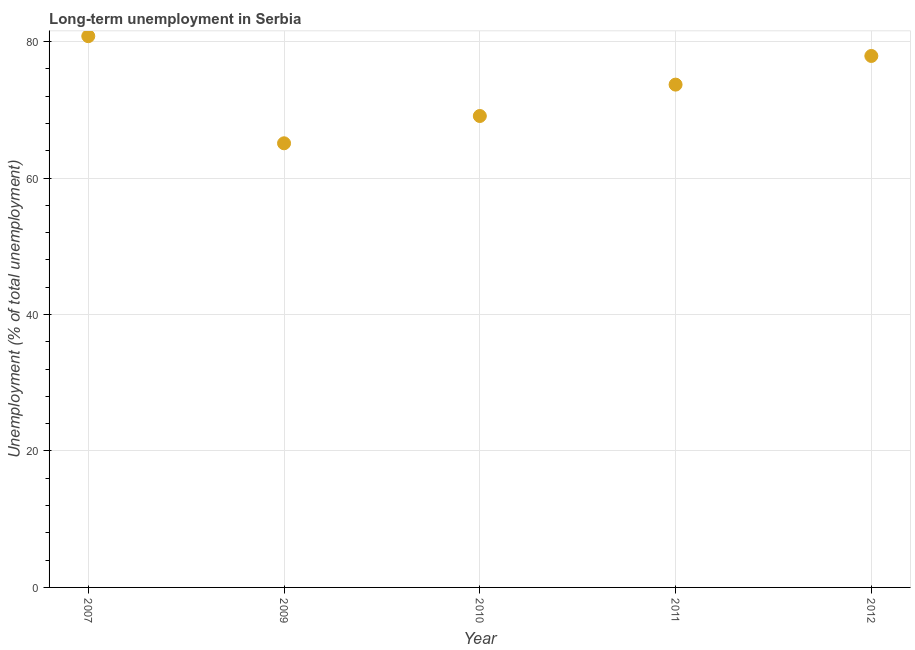What is the long-term unemployment in 2010?
Your answer should be very brief. 69.1. Across all years, what is the maximum long-term unemployment?
Offer a terse response. 80.8. Across all years, what is the minimum long-term unemployment?
Make the answer very short. 65.1. In which year was the long-term unemployment maximum?
Your answer should be compact. 2007. In which year was the long-term unemployment minimum?
Your answer should be compact. 2009. What is the sum of the long-term unemployment?
Your answer should be compact. 366.6. What is the difference between the long-term unemployment in 2009 and 2011?
Offer a very short reply. -8.6. What is the average long-term unemployment per year?
Your answer should be compact. 73.32. What is the median long-term unemployment?
Offer a terse response. 73.7. Do a majority of the years between 2010 and 2012 (inclusive) have long-term unemployment greater than 16 %?
Ensure brevity in your answer.  Yes. What is the ratio of the long-term unemployment in 2009 to that in 2010?
Provide a succinct answer. 0.94. Is the long-term unemployment in 2007 less than that in 2009?
Provide a short and direct response. No. What is the difference between the highest and the second highest long-term unemployment?
Your response must be concise. 2.9. What is the difference between the highest and the lowest long-term unemployment?
Make the answer very short. 15.7. Are the values on the major ticks of Y-axis written in scientific E-notation?
Offer a terse response. No. Does the graph contain any zero values?
Ensure brevity in your answer.  No. What is the title of the graph?
Offer a terse response. Long-term unemployment in Serbia. What is the label or title of the X-axis?
Your answer should be very brief. Year. What is the label or title of the Y-axis?
Give a very brief answer. Unemployment (% of total unemployment). What is the Unemployment (% of total unemployment) in 2007?
Your response must be concise. 80.8. What is the Unemployment (% of total unemployment) in 2009?
Make the answer very short. 65.1. What is the Unemployment (% of total unemployment) in 2010?
Your response must be concise. 69.1. What is the Unemployment (% of total unemployment) in 2011?
Make the answer very short. 73.7. What is the Unemployment (% of total unemployment) in 2012?
Provide a short and direct response. 77.9. What is the difference between the Unemployment (% of total unemployment) in 2007 and 2011?
Provide a short and direct response. 7.1. What is the difference between the Unemployment (% of total unemployment) in 2009 and 2010?
Your response must be concise. -4. What is the difference between the Unemployment (% of total unemployment) in 2009 and 2011?
Your answer should be compact. -8.6. What is the difference between the Unemployment (% of total unemployment) in 2009 and 2012?
Your response must be concise. -12.8. What is the difference between the Unemployment (% of total unemployment) in 2010 and 2011?
Your answer should be compact. -4.6. What is the difference between the Unemployment (% of total unemployment) in 2010 and 2012?
Make the answer very short. -8.8. What is the ratio of the Unemployment (% of total unemployment) in 2007 to that in 2009?
Give a very brief answer. 1.24. What is the ratio of the Unemployment (% of total unemployment) in 2007 to that in 2010?
Make the answer very short. 1.17. What is the ratio of the Unemployment (% of total unemployment) in 2007 to that in 2011?
Keep it short and to the point. 1.1. What is the ratio of the Unemployment (% of total unemployment) in 2007 to that in 2012?
Provide a succinct answer. 1.04. What is the ratio of the Unemployment (% of total unemployment) in 2009 to that in 2010?
Make the answer very short. 0.94. What is the ratio of the Unemployment (% of total unemployment) in 2009 to that in 2011?
Offer a very short reply. 0.88. What is the ratio of the Unemployment (% of total unemployment) in 2009 to that in 2012?
Offer a very short reply. 0.84. What is the ratio of the Unemployment (% of total unemployment) in 2010 to that in 2011?
Ensure brevity in your answer.  0.94. What is the ratio of the Unemployment (% of total unemployment) in 2010 to that in 2012?
Provide a short and direct response. 0.89. What is the ratio of the Unemployment (% of total unemployment) in 2011 to that in 2012?
Keep it short and to the point. 0.95. 